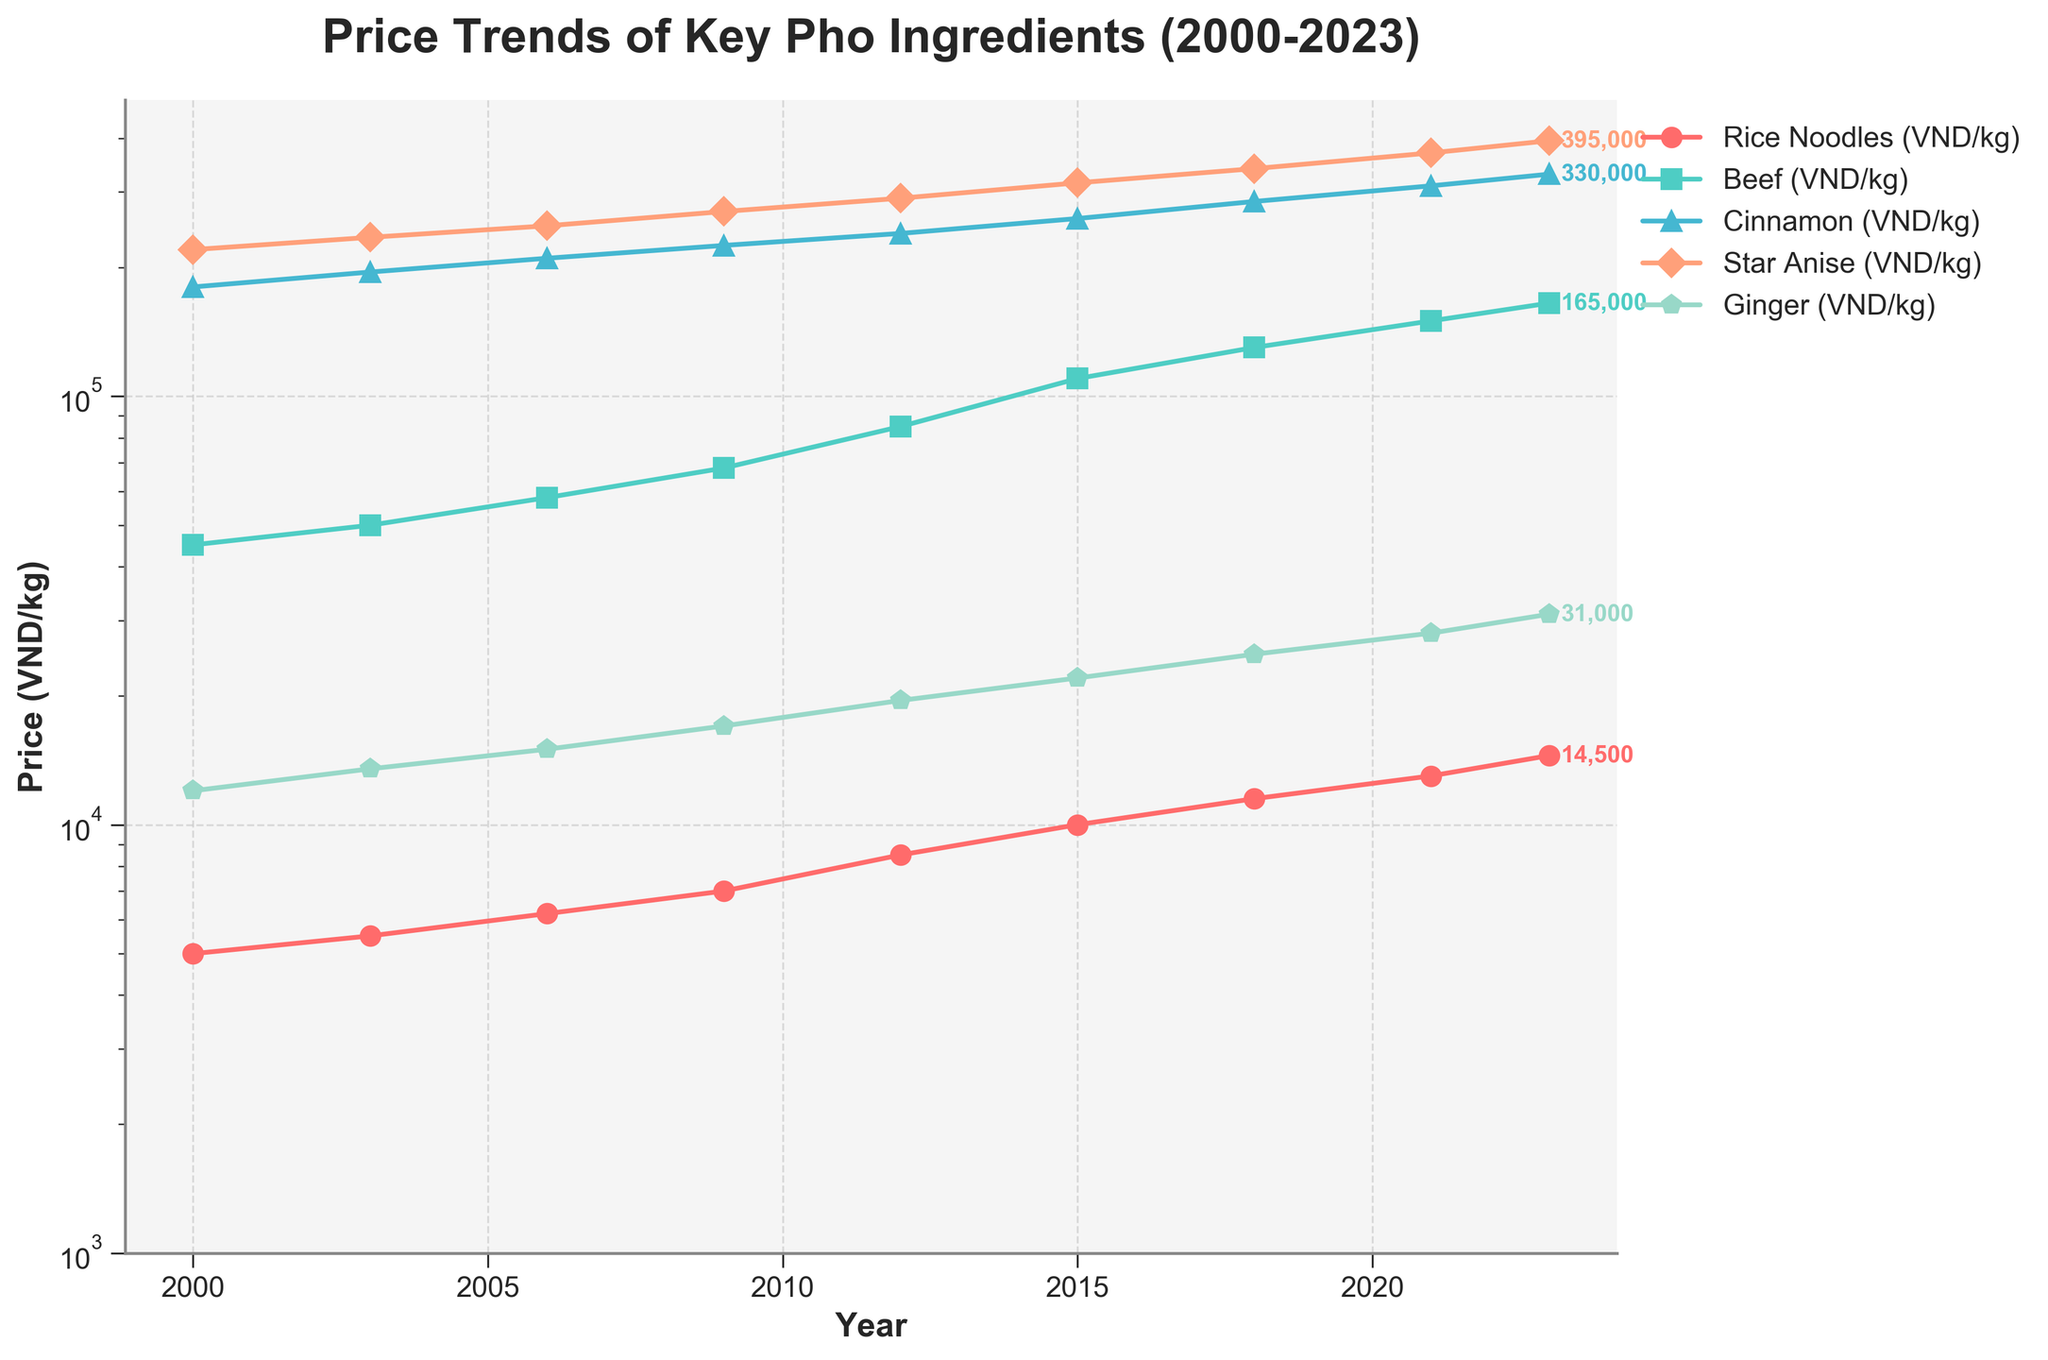What was the price of rice noodles in 2023? Look for the value labeled for rice noodles (red line) in the year 2023.
Answer: 14,500 VND/kg Which ingredient had the highest price in 2023? Compare the ending values across all ingredient lines in 2023. Beef (165,000 VND/kg), Cinnamon (330,000 VND/kg), Star Anise (395,000 VND/kg), Ginger (31,000 VND/kg)
Answer: Star Anise By how much did the price of beef increase from 2000 to 2023? Find the starting (2000) and ending (2023) values for the beef line, and subtract the starting value from the ending value: 165,000 VND/kg - 45,000 VND/kg.
Answer: 120,000 VND/kg What is the average price of ginger from 2015 to 2023? Find the values for ginger in 2015 (22,000 VND/kg), 2018 (25,000 VND/kg), 2021 (28,000 VND/kg), and 2023 (31,000 VND/kg). Calculate the average: (22,000 + 25,000 + 28,000 + 31,000) / 4.
Answer: 26,500 VND/kg Which ingredient had the smallest overall price increase between 2000 and 2023? Calculate the difference between the 2023 and 2000 prices for each ingredient. Compare the increases: Rice Noodles (14,500 - 5,000 = 9,500 VND), Beef (165,000 - 45,000 = 120,000 VND), Cinnamon (330,000 - 180,000 = 150,000 VND), Star Anise (395,000 - 220,000 = 175,000 VND), Ginger (31,000 - 12,000 = 19,000 VND).
Answer: Rice Noodles In which year did cinnamon reach a price of 240,000 VND/kg? Look along the cinnamon line (blue) for the year when the price is 240,000 VND/kg.
Answer: 2012 What was the trend for the price of spices (cinnamon, star anise, ginger) from 2018 to 2023? Observe the line patterns for cinnamon, star anise, and ginger from 2018 to 2023. All lines show a consistent upward trend.
Answer: Increasing Which ingredient had the highest growth rate between 2000 and 2023? Calculate the growth rate for each ingredient by dividing the price increase by the 2000 price: Rice Noodles (9,500/5,000 = 1.9), Beef (120,000/45,000 = 2.67), Cinnamon (150,000/180,000 = 0.83), Star Anise (175,000/220,000 = 0.8), Ginger (19,000/12,000 = 1.58).
Answer: Beef 